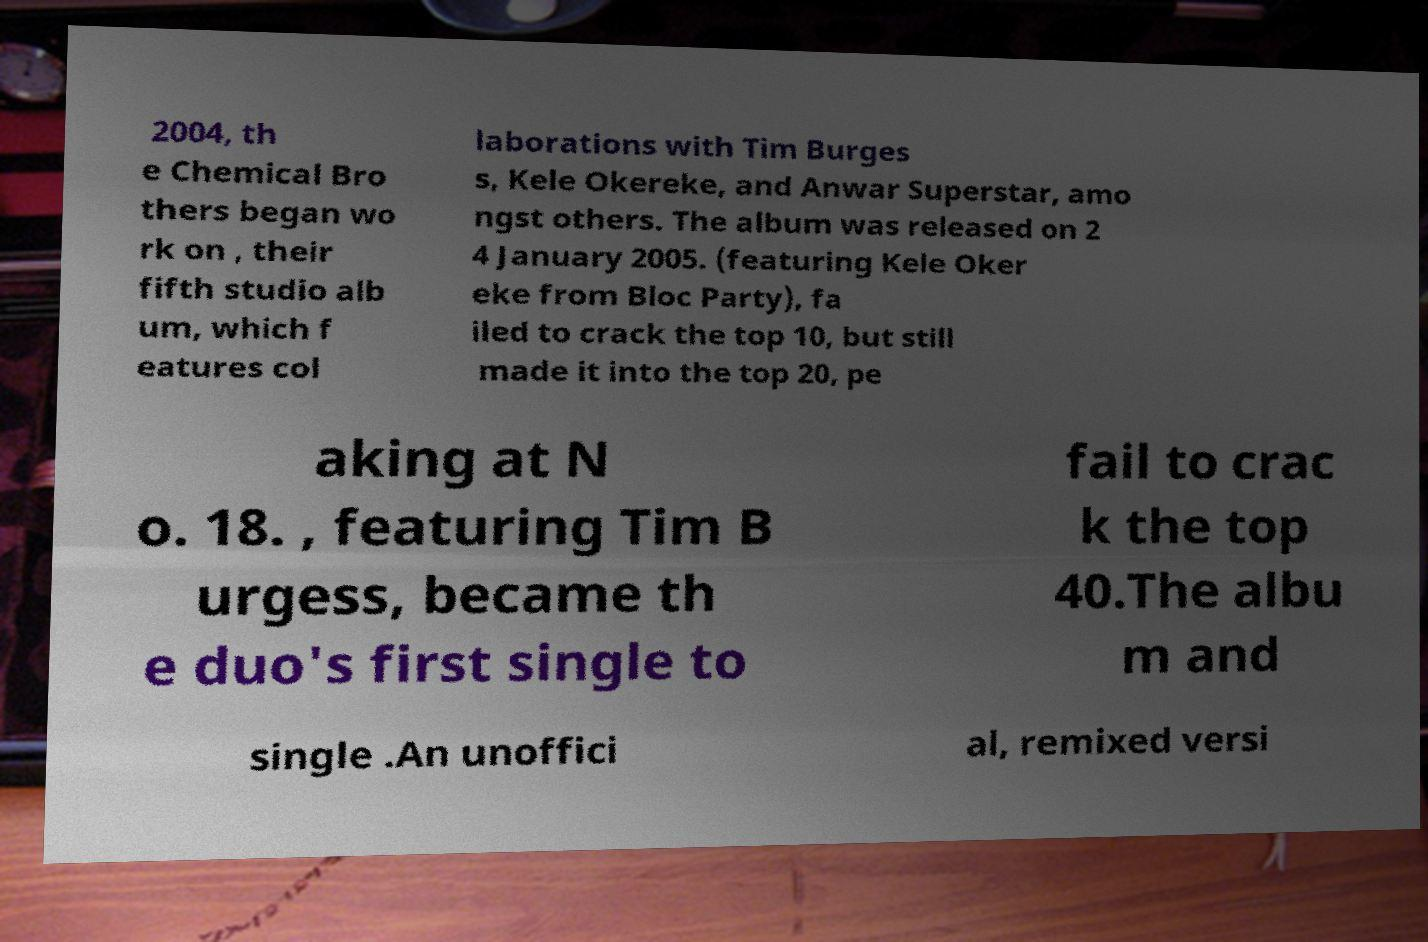What messages or text are displayed in this image? I need them in a readable, typed format. 2004, th e Chemical Bro thers began wo rk on , their fifth studio alb um, which f eatures col laborations with Tim Burges s, Kele Okereke, and Anwar Superstar, amo ngst others. The album was released on 2 4 January 2005. (featuring Kele Oker eke from Bloc Party), fa iled to crack the top 10, but still made it into the top 20, pe aking at N o. 18. , featuring Tim B urgess, became th e duo's first single to fail to crac k the top 40.The albu m and single .An unoffici al, remixed versi 